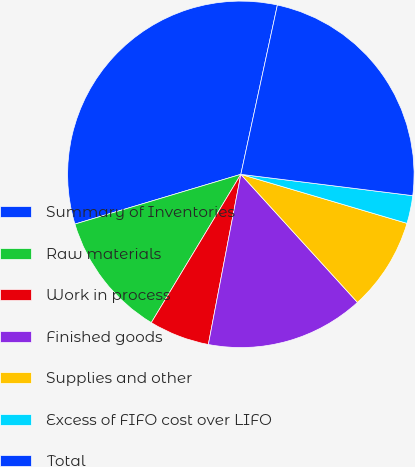<chart> <loc_0><loc_0><loc_500><loc_500><pie_chart><fcel>Summary of Inventories<fcel>Raw materials<fcel>Work in process<fcel>Finished goods<fcel>Supplies and other<fcel>Excess of FIFO cost over LIFO<fcel>Total<nl><fcel>33.02%<fcel>11.72%<fcel>5.64%<fcel>14.76%<fcel>8.68%<fcel>2.6%<fcel>23.58%<nl></chart> 